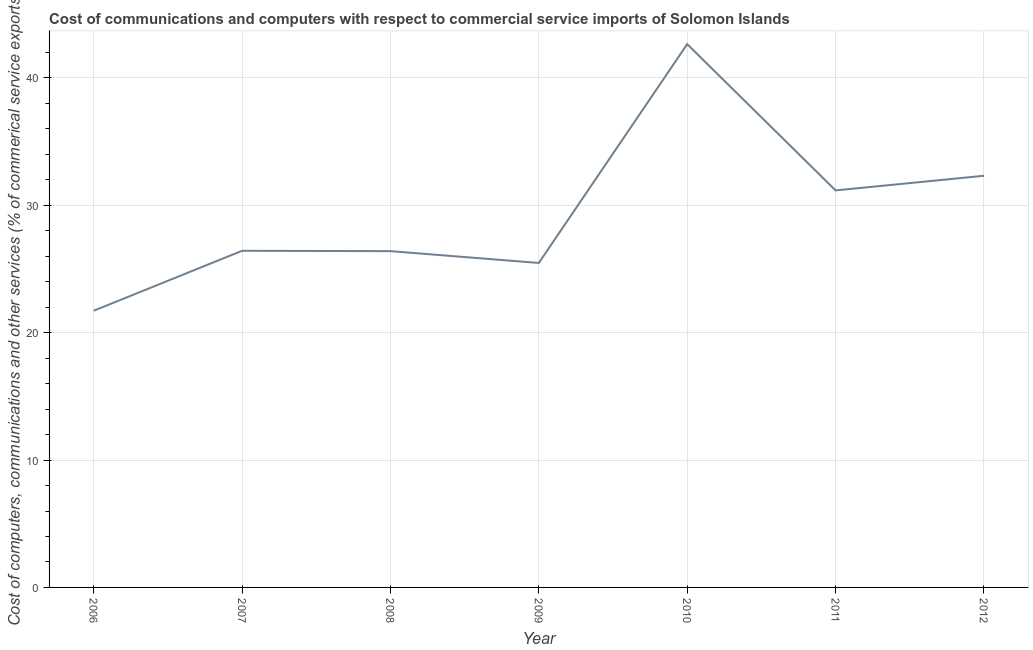What is the cost of communications in 2009?
Provide a short and direct response. 25.47. Across all years, what is the maximum cost of communications?
Provide a short and direct response. 42.65. Across all years, what is the minimum  computer and other services?
Give a very brief answer. 21.72. In which year was the cost of communications maximum?
Ensure brevity in your answer.  2010. In which year was the cost of communications minimum?
Keep it short and to the point. 2006. What is the sum of the  computer and other services?
Keep it short and to the point. 206.16. What is the difference between the cost of communications in 2010 and 2011?
Your answer should be very brief. 11.48. What is the average  computer and other services per year?
Provide a succinct answer. 29.45. What is the median  computer and other services?
Your answer should be compact. 26.43. Do a majority of the years between 2009 and 2007 (inclusive) have  computer and other services greater than 14 %?
Your answer should be very brief. No. What is the ratio of the  computer and other services in 2006 to that in 2010?
Provide a short and direct response. 0.51. What is the difference between the highest and the second highest  computer and other services?
Give a very brief answer. 10.33. Is the sum of the cost of communications in 2006 and 2007 greater than the maximum cost of communications across all years?
Your answer should be compact. Yes. What is the difference between the highest and the lowest cost of communications?
Keep it short and to the point. 20.93. Does the  computer and other services monotonically increase over the years?
Ensure brevity in your answer.  No. How many lines are there?
Your answer should be very brief. 1. How many years are there in the graph?
Keep it short and to the point. 7. What is the difference between two consecutive major ticks on the Y-axis?
Offer a terse response. 10. Are the values on the major ticks of Y-axis written in scientific E-notation?
Your response must be concise. No. Does the graph contain any zero values?
Make the answer very short. No. Does the graph contain grids?
Offer a terse response. Yes. What is the title of the graph?
Your answer should be compact. Cost of communications and computers with respect to commercial service imports of Solomon Islands. What is the label or title of the X-axis?
Offer a very short reply. Year. What is the label or title of the Y-axis?
Ensure brevity in your answer.  Cost of computers, communications and other services (% of commerical service exports). What is the Cost of computers, communications and other services (% of commerical service exports) of 2006?
Offer a very short reply. 21.72. What is the Cost of computers, communications and other services (% of commerical service exports) of 2007?
Provide a succinct answer. 26.43. What is the Cost of computers, communications and other services (% of commerical service exports) in 2008?
Ensure brevity in your answer.  26.4. What is the Cost of computers, communications and other services (% of commerical service exports) in 2009?
Ensure brevity in your answer.  25.47. What is the Cost of computers, communications and other services (% of commerical service exports) of 2010?
Your answer should be compact. 42.65. What is the Cost of computers, communications and other services (% of commerical service exports) in 2011?
Offer a terse response. 31.17. What is the Cost of computers, communications and other services (% of commerical service exports) of 2012?
Your answer should be very brief. 32.32. What is the difference between the Cost of computers, communications and other services (% of commerical service exports) in 2006 and 2007?
Provide a short and direct response. -4.71. What is the difference between the Cost of computers, communications and other services (% of commerical service exports) in 2006 and 2008?
Provide a succinct answer. -4.68. What is the difference between the Cost of computers, communications and other services (% of commerical service exports) in 2006 and 2009?
Provide a short and direct response. -3.75. What is the difference between the Cost of computers, communications and other services (% of commerical service exports) in 2006 and 2010?
Offer a very short reply. -20.93. What is the difference between the Cost of computers, communications and other services (% of commerical service exports) in 2006 and 2011?
Offer a very short reply. -9.45. What is the difference between the Cost of computers, communications and other services (% of commerical service exports) in 2006 and 2012?
Provide a short and direct response. -10.6. What is the difference between the Cost of computers, communications and other services (% of commerical service exports) in 2007 and 2008?
Make the answer very short. 0.03. What is the difference between the Cost of computers, communications and other services (% of commerical service exports) in 2007 and 2009?
Your response must be concise. 0.95. What is the difference between the Cost of computers, communications and other services (% of commerical service exports) in 2007 and 2010?
Offer a terse response. -16.22. What is the difference between the Cost of computers, communications and other services (% of commerical service exports) in 2007 and 2011?
Your answer should be very brief. -4.74. What is the difference between the Cost of computers, communications and other services (% of commerical service exports) in 2007 and 2012?
Your response must be concise. -5.89. What is the difference between the Cost of computers, communications and other services (% of commerical service exports) in 2008 and 2009?
Give a very brief answer. 0.93. What is the difference between the Cost of computers, communications and other services (% of commerical service exports) in 2008 and 2010?
Ensure brevity in your answer.  -16.25. What is the difference between the Cost of computers, communications and other services (% of commerical service exports) in 2008 and 2011?
Your response must be concise. -4.77. What is the difference between the Cost of computers, communications and other services (% of commerical service exports) in 2008 and 2012?
Give a very brief answer. -5.92. What is the difference between the Cost of computers, communications and other services (% of commerical service exports) in 2009 and 2010?
Your response must be concise. -17.18. What is the difference between the Cost of computers, communications and other services (% of commerical service exports) in 2009 and 2011?
Your answer should be very brief. -5.7. What is the difference between the Cost of computers, communications and other services (% of commerical service exports) in 2009 and 2012?
Keep it short and to the point. -6.85. What is the difference between the Cost of computers, communications and other services (% of commerical service exports) in 2010 and 2011?
Ensure brevity in your answer.  11.48. What is the difference between the Cost of computers, communications and other services (% of commerical service exports) in 2010 and 2012?
Your answer should be compact. 10.33. What is the difference between the Cost of computers, communications and other services (% of commerical service exports) in 2011 and 2012?
Your answer should be very brief. -1.15. What is the ratio of the Cost of computers, communications and other services (% of commerical service exports) in 2006 to that in 2007?
Offer a very short reply. 0.82. What is the ratio of the Cost of computers, communications and other services (% of commerical service exports) in 2006 to that in 2008?
Provide a short and direct response. 0.82. What is the ratio of the Cost of computers, communications and other services (% of commerical service exports) in 2006 to that in 2009?
Offer a very short reply. 0.85. What is the ratio of the Cost of computers, communications and other services (% of commerical service exports) in 2006 to that in 2010?
Your response must be concise. 0.51. What is the ratio of the Cost of computers, communications and other services (% of commerical service exports) in 2006 to that in 2011?
Your response must be concise. 0.7. What is the ratio of the Cost of computers, communications and other services (% of commerical service exports) in 2006 to that in 2012?
Make the answer very short. 0.67. What is the ratio of the Cost of computers, communications and other services (% of commerical service exports) in 2007 to that in 2009?
Ensure brevity in your answer.  1.04. What is the ratio of the Cost of computers, communications and other services (% of commerical service exports) in 2007 to that in 2010?
Make the answer very short. 0.62. What is the ratio of the Cost of computers, communications and other services (% of commerical service exports) in 2007 to that in 2011?
Your answer should be compact. 0.85. What is the ratio of the Cost of computers, communications and other services (% of commerical service exports) in 2007 to that in 2012?
Give a very brief answer. 0.82. What is the ratio of the Cost of computers, communications and other services (% of commerical service exports) in 2008 to that in 2009?
Provide a succinct answer. 1.04. What is the ratio of the Cost of computers, communications and other services (% of commerical service exports) in 2008 to that in 2010?
Your answer should be very brief. 0.62. What is the ratio of the Cost of computers, communications and other services (% of commerical service exports) in 2008 to that in 2011?
Your answer should be very brief. 0.85. What is the ratio of the Cost of computers, communications and other services (% of commerical service exports) in 2008 to that in 2012?
Your answer should be very brief. 0.82. What is the ratio of the Cost of computers, communications and other services (% of commerical service exports) in 2009 to that in 2010?
Provide a succinct answer. 0.6. What is the ratio of the Cost of computers, communications and other services (% of commerical service exports) in 2009 to that in 2011?
Give a very brief answer. 0.82. What is the ratio of the Cost of computers, communications and other services (% of commerical service exports) in 2009 to that in 2012?
Provide a short and direct response. 0.79. What is the ratio of the Cost of computers, communications and other services (% of commerical service exports) in 2010 to that in 2011?
Provide a succinct answer. 1.37. What is the ratio of the Cost of computers, communications and other services (% of commerical service exports) in 2010 to that in 2012?
Your response must be concise. 1.32. 